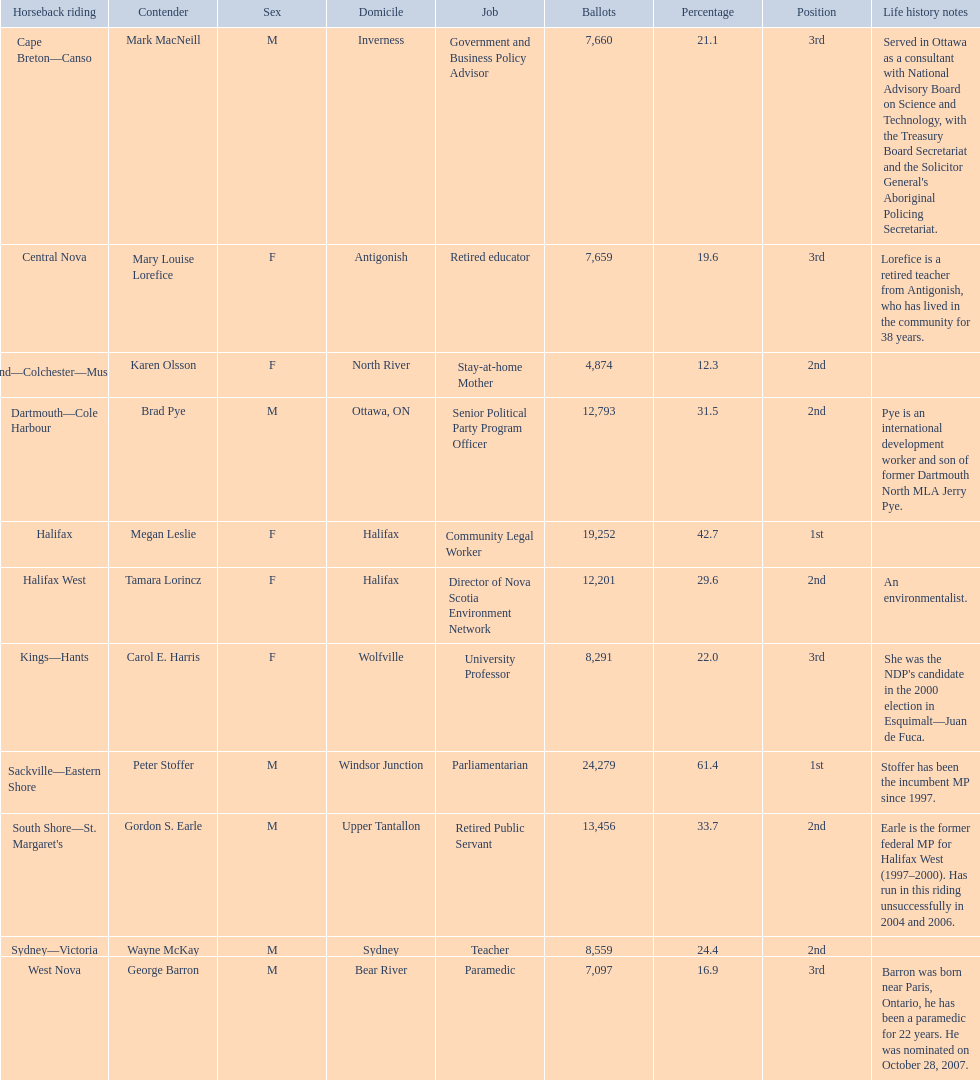Parse the table in full. {'header': ['Horseback riding', 'Contender', 'Sex', 'Domicile', 'Job', 'Ballots', 'Percentage', 'Position', 'Life history notes'], 'rows': [['Cape Breton—Canso', 'Mark MacNeill', 'M', 'Inverness', 'Government and Business Policy Advisor', '7,660', '21.1', '3rd', "Served in Ottawa as a consultant with National Advisory Board on Science and Technology, with the Treasury Board Secretariat and the Solicitor General's Aboriginal Policing Secretariat."], ['Central Nova', 'Mary Louise Lorefice', 'F', 'Antigonish', 'Retired educator', '7,659', '19.6', '3rd', 'Lorefice is a retired teacher from Antigonish, who has lived in the community for 38 years.'], ['Cumberland—Colchester—Musquodoboit Valley', 'Karen Olsson', 'F', 'North River', 'Stay-at-home Mother', '4,874', '12.3', '2nd', ''], ['Dartmouth—Cole Harbour', 'Brad Pye', 'M', 'Ottawa, ON', 'Senior Political Party Program Officer', '12,793', '31.5', '2nd', 'Pye is an international development worker and son of former Dartmouth North MLA Jerry Pye.'], ['Halifax', 'Megan Leslie', 'F', 'Halifax', 'Community Legal Worker', '19,252', '42.7', '1st', ''], ['Halifax West', 'Tamara Lorincz', 'F', 'Halifax', 'Director of Nova Scotia Environment Network', '12,201', '29.6', '2nd', 'An environmentalist.'], ['Kings—Hants', 'Carol E. Harris', 'F', 'Wolfville', 'University Professor', '8,291', '22.0', '3rd', "She was the NDP's candidate in the 2000 election in Esquimalt—Juan de Fuca."], ['Sackville—Eastern Shore', 'Peter Stoffer', 'M', 'Windsor Junction', 'Parliamentarian', '24,279', '61.4', '1st', 'Stoffer has been the incumbent MP since 1997.'], ["South Shore—St. Margaret's", 'Gordon S. Earle', 'M', 'Upper Tantallon', 'Retired Public Servant', '13,456', '33.7', '2nd', 'Earle is the former federal MP for Halifax West (1997–2000). Has run in this riding unsuccessfully in 2004 and 2006.'], ['Sydney—Victoria', 'Wayne McKay', 'M', 'Sydney', 'Teacher', '8,559', '24.4', '2nd', ''], ['West Nova', 'George Barron', 'M', 'Bear River', 'Paramedic', '7,097', '16.9', '3rd', 'Barron was born near Paris, Ontario, he has been a paramedic for 22 years. He was nominated on October 28, 2007.']]} How many candidates were from halifax? 2. 